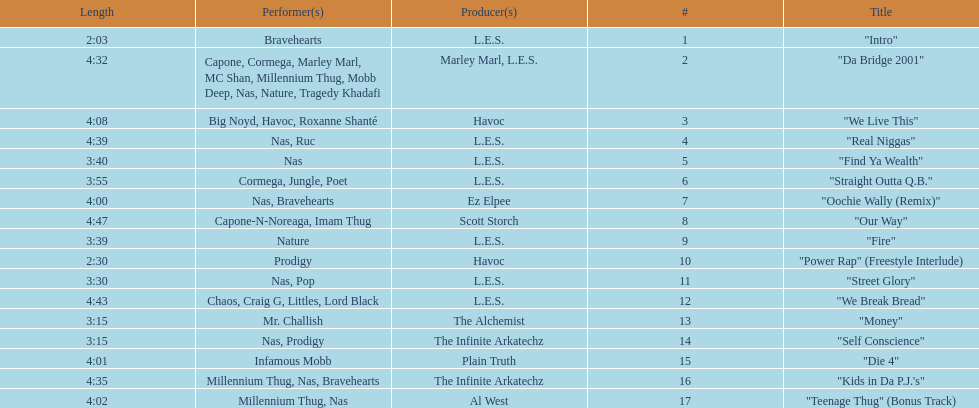Which is longer, fire or die 4? "Die 4". 